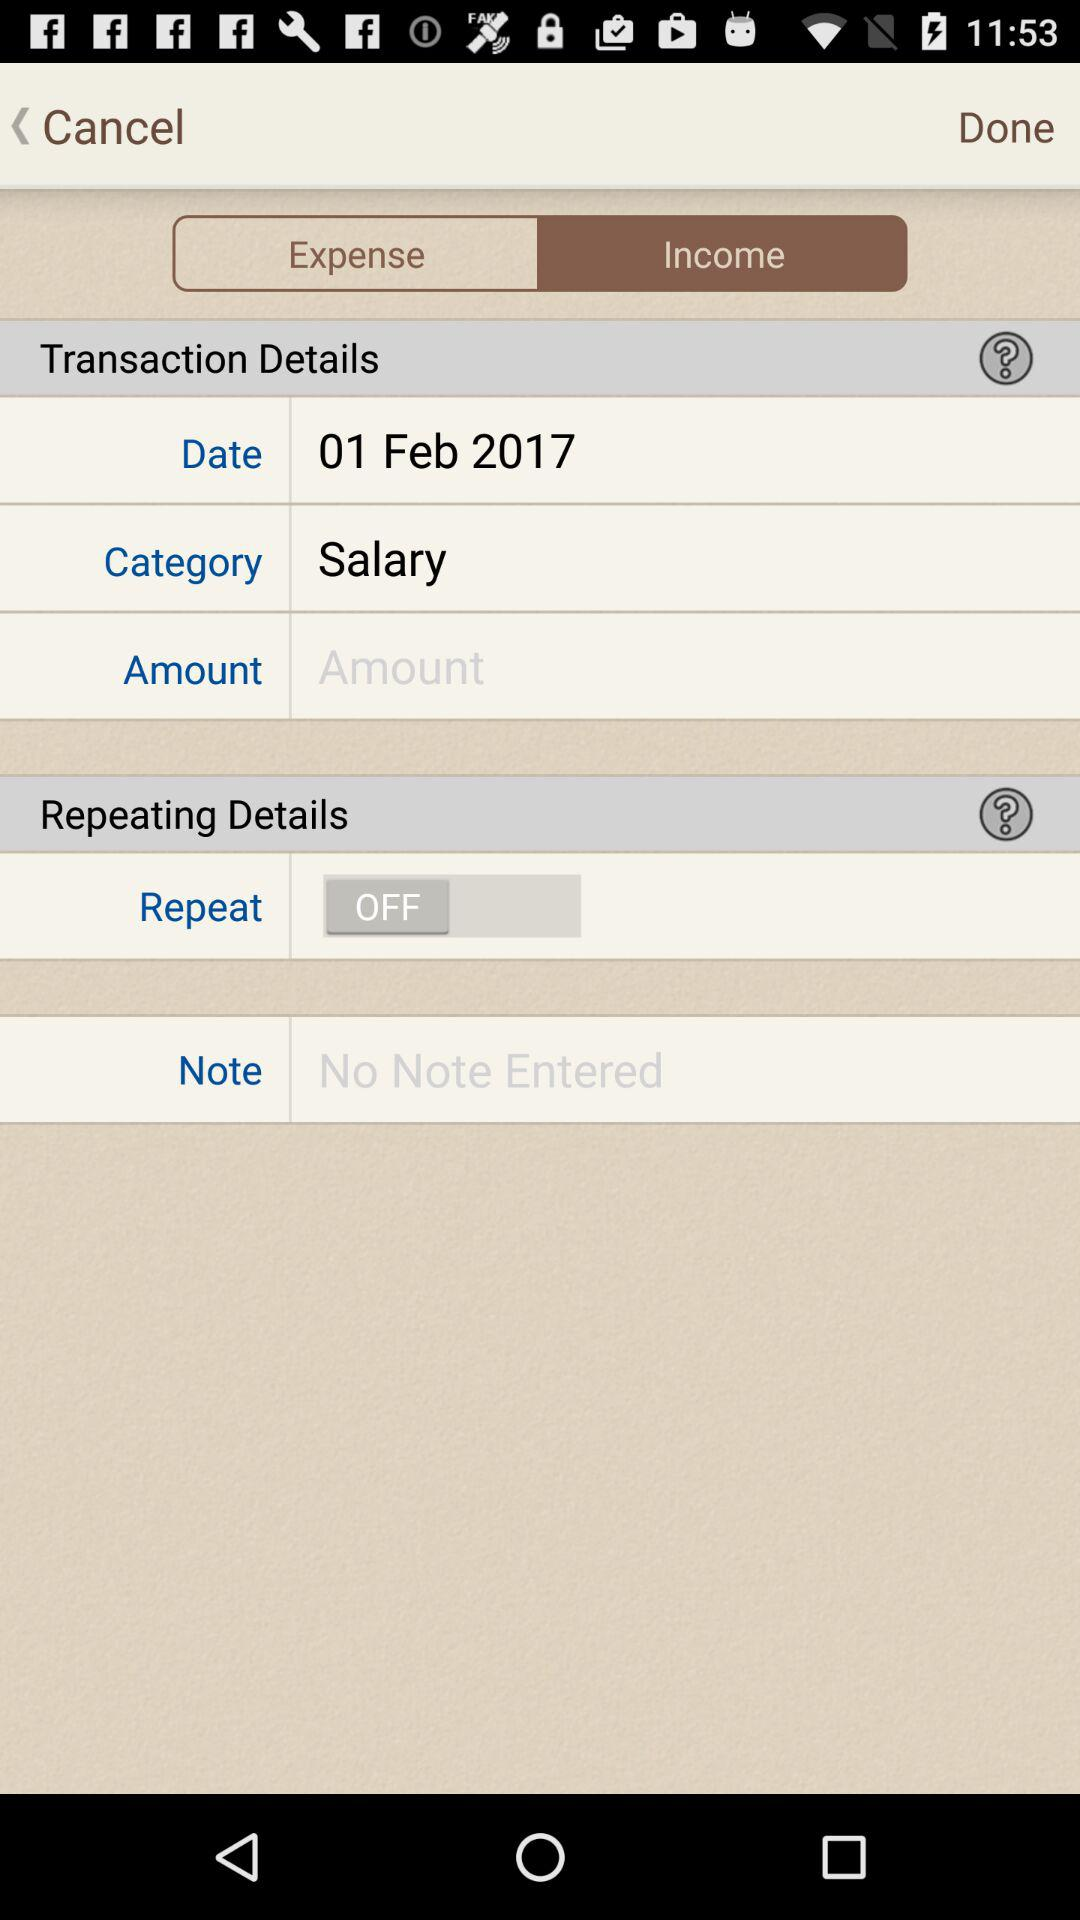What is the date? The date is February 1, 2017. 